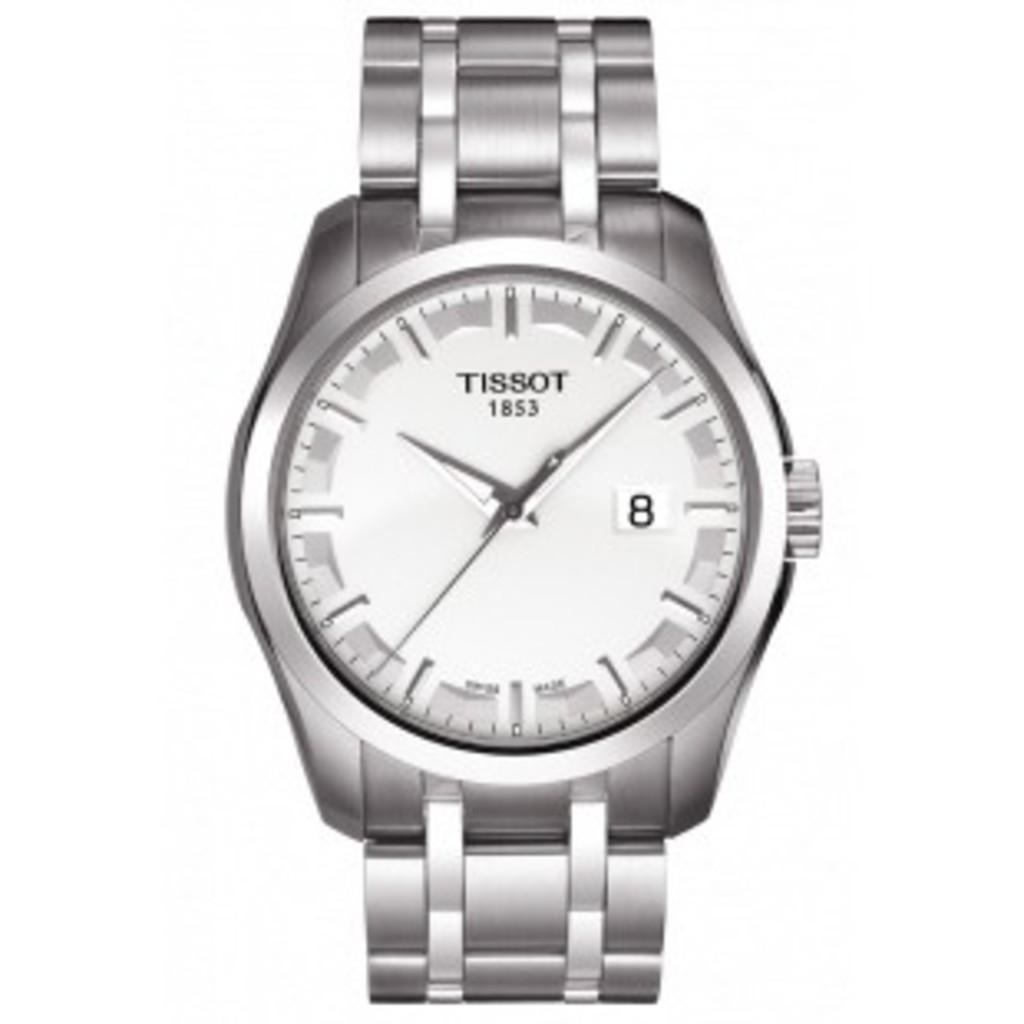Provide a one-sentence caption for the provided image. A silver watch that says Tissot 1853 at the top of the watch face. 